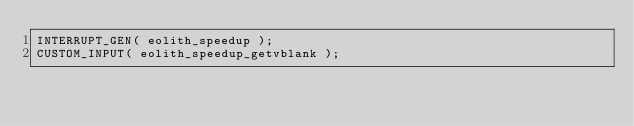Convert code to text. <code><loc_0><loc_0><loc_500><loc_500><_C_>INTERRUPT_GEN( eolith_speedup );
CUSTOM_INPUT( eolith_speedup_getvblank );
</code> 